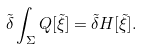Convert formula to latex. <formula><loc_0><loc_0><loc_500><loc_500>\tilde { \delta } \int _ { \Sigma } { Q } [ \tilde { \xi } ] = \tilde { \delta } H [ \tilde { \xi } ] .</formula> 